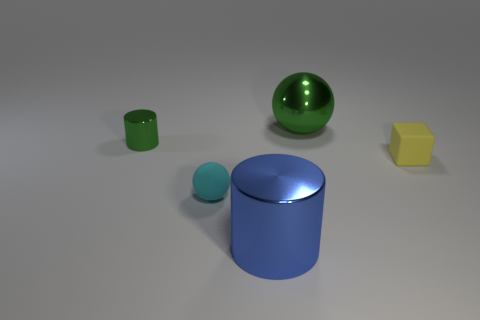Subtract all red cubes. Subtract all green cylinders. How many cubes are left? 1 Add 4 small gray shiny things. How many objects exist? 9 Subtract all cubes. How many objects are left? 4 Add 4 tiny yellow rubber things. How many tiny yellow rubber things exist? 5 Subtract 0 cyan cylinders. How many objects are left? 5 Subtract all blocks. Subtract all green metal balls. How many objects are left? 3 Add 2 matte things. How many matte things are left? 4 